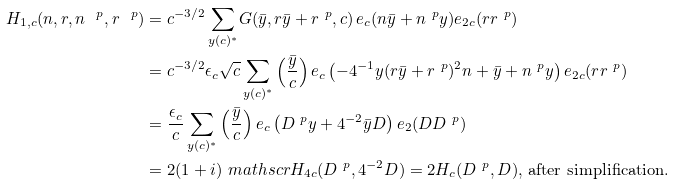Convert formula to latex. <formula><loc_0><loc_0><loc_500><loc_500>H _ { 1 , c } ( n , r , n ^ { \ p } , r ^ { \ p } ) & = c ^ { - 3 / 2 } \, \underset { y ( c ) ^ { * } } \sum G ( \bar { y } , r \bar { y } + r ^ { \ p } , c ) \, e _ { c } ( n \bar { y } + n ^ { \ p } y ) e _ { 2 c } ( r r ^ { \ p } ) \\ & = c ^ { - 3 / 2 } \epsilon _ { c } \sqrt { c } \, \underset { y ( c ) ^ { * } } \sum \left ( \frac { \bar { y } } { c } \right ) e _ { c } \left ( - 4 ^ { - 1 } y ( r \bar { y } + r ^ { \ p } ) ^ { 2 } n + \bar { y } + n ^ { \ p } y \right ) e _ { 2 c } ( r r ^ { \ p } ) \\ & = \frac { \epsilon _ { c } } { c } \, \underset { y ( c ) ^ { * } } \sum \left ( \frac { \bar { y } } { c } \right ) e _ { c } \left ( D ^ { \ p } y + 4 ^ { - 2 } \bar { y } D \right ) e _ { 2 } ( D D ^ { \ p } ) \\ & = 2 ( 1 + i ) \ m a t h s c r { H } _ { 4 c } ( D ^ { \ p } , 4 ^ { - 2 } D ) = 2 H _ { c } ( D ^ { \ p } , D ) , \, \text {after simplification} .</formula> 